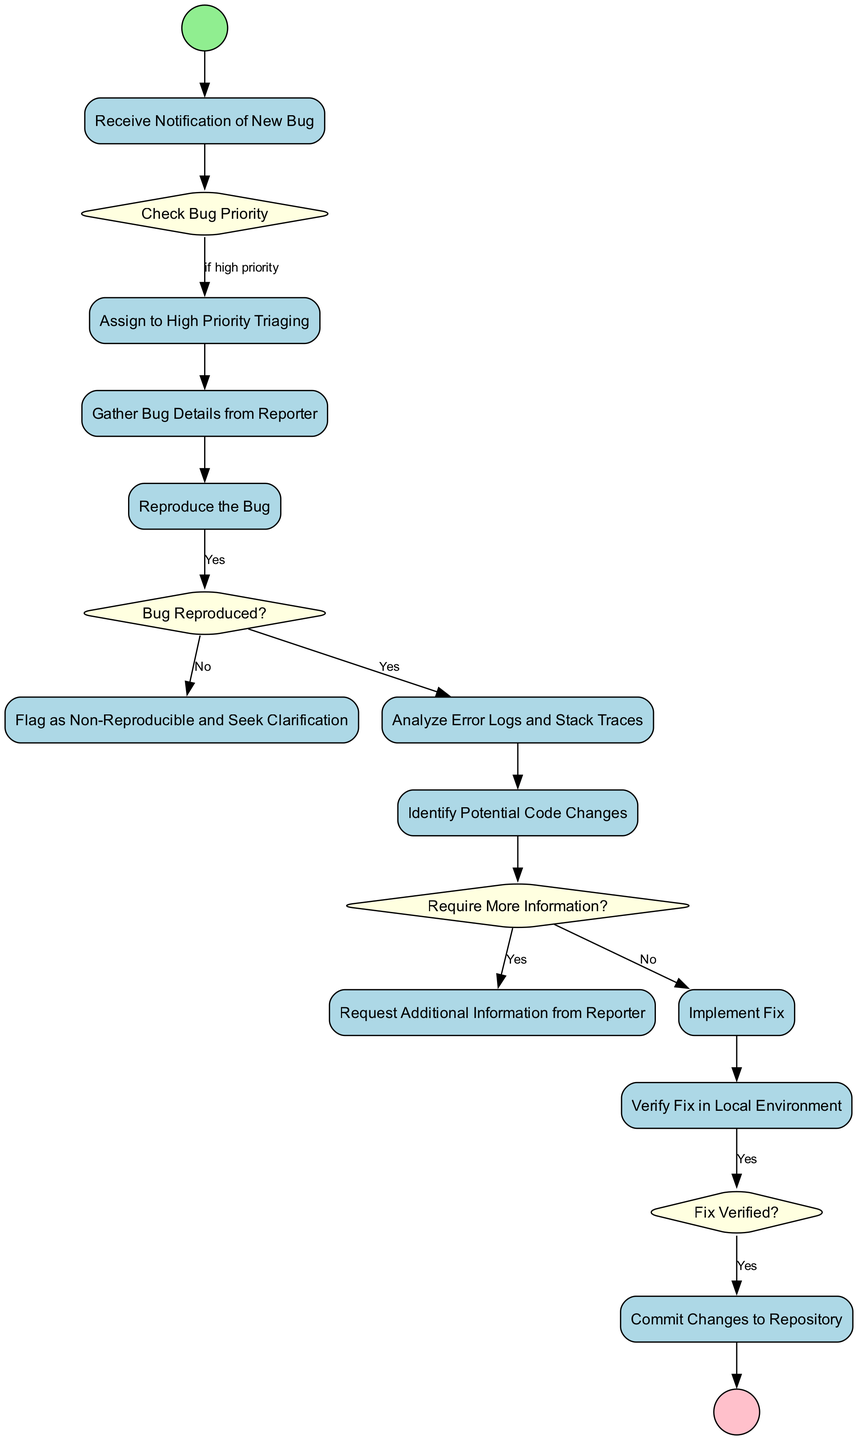What is the first step when a bug is reported? The first node in the diagram is labeled "Bug Reported," indicating that this is the initial event in the workflow of triaging and resolving a bug.
Answer: Bug Reported How many decision nodes are in the diagram? The diagram contains three decision nodes: "Check Bug Priority," "Bug Reproduced?," and "Require More Information?" which can be counted by examining the shapes labeled as diamonds.
Answer: 3 What happens if the bug is flagged as non-reproducible? According to the diagram, if the bug is not reproduced, the flow leads to the activity "Flag as Non-Reproducible and Seek Clarification," which is connected to the decision node "Bug Reproduced?" where "No" is the guard label.
Answer: Flag as Non-Reproducible and Seek Clarification What is the outcome if the fix is verified? If the fix verification is successful (guard is "Yes"), the flow moves to the activity "Commit Changes to Repository," signaling that the changes are finalized and ready to be saved.
Answer: Commit Changes to Repository What activity immediately follows gathering bug details? The diagram shows a direct transition from the activity "Gather Bug Details from Reporter" to "Reproduce the Bug," indicating that reproducing the bug follows after gathering details.
Answer: Reproduce the Bug What is required if the analysis indicates that more information is needed? The flow from the decision node "Require More Information?" points to "Request Additional Information from Reporter," which must occur if the guard is "Yes."
Answer: Request Additional Information from Reporter What is the last activity before notifying the bug reporter? The final activity that occurs before notifying the reporter is "Commit Changes to Repository," as shown by the flow leading up to the end event.
Answer: Commit Changes to Repository What is the decision that determines if the bug can be reproduced? The decision "Bug Reproduced?" is critical, as it assesses whether the efforts to reproduce the bug were successful, controlling the next steps based on the response.
Answer: Bug Reproduced? 